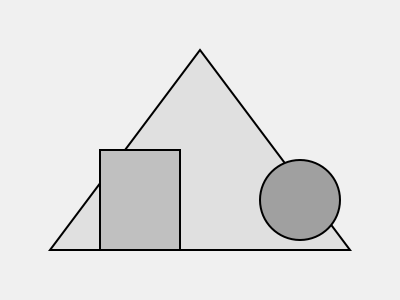Analyze the abstract stage set design shown above. Which principle of visual composition is most prominently utilized to create balance in this arrangement? To analyze the visual composition and balance in this abstract stage set design, let's consider the following steps:

1. Identify the main elements:
   - A large triangular shape (backdrop)
   - A rectangular shape (stage left)
   - A circular shape (stage right)
   - A horizontal line (stage floor)

2. Observe the placement of elements:
   - The triangle is centered and dominates the composition
   - The rectangle and circle are placed on opposite sides of the stage
   - The horizontal line grounds all elements

3. Analyze the visual weight:
   - The triangle has the largest area and lightest shade
   - The rectangle and circle have similar sizes but different shapes
   - The circle has a darker shade than the rectangle

4. Consider the principles of composition:
   - Symmetry: The overall composition is not perfectly symmetrical
   - Asymmetrical balance: Different shapes and shades create interest
   - Rule of thirds: Elements are placed near intersection points
   - Golden ratio: Not explicitly used in this composition

5. Evaluate the balance:
   - The centered triangle creates a stable base
   - The rectangle and circle counterbalance each other
   - Their different shapes and shades create visual interest
   - The horizontal line unifies the composition

Considering these factors, the most prominent principle used to create balance in this arrangement is asymmetrical balance. The composition achieves equilibrium through the strategic placement of different shapes and shades, rather than through perfect symmetry.
Answer: Asymmetrical balance 